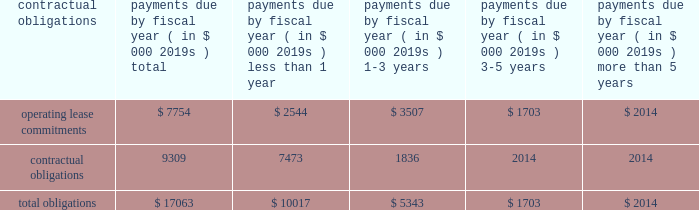97% ( 97 % ) of its carrying value .
The columbia fund is being liquidated with distributions to us occurring and expected to be fully liquidated during calendar 2008 .
Since december 2007 , we have received disbursements of approximately $ 20.7 million from the columbia fund .
Our operating activities during the year ended march 31 , 2008 used cash of $ 28.9 million as compared to $ 19.8 million during the same period in the prior year .
Our fiscal 2008 net loss of $ 40.9 million was the primary cause of our cash use from operations , attributed to increased investments in our global distribution as we continue to drive initiatives to increase recovery awareness as well as our investments in research and development to broaden our circulatory care product portfolio .
In addition , our inventories used cash of $ 11.1 million during fiscal 2008 , reflecting our inventory build-up to support anticipated increases in global demand for our products and our accounts receivable also increased as a result of higher sales volume resulting in a use of cash of $ 2.8 million in fiscal 2008 .
These decreases in cash were partially offset by an increase in accounts payable and accrued expenses of $ 5.6 million , non-cash adjustments of $ 5.4 million related to stock-based compensation expense , $ 6.1 million of depreciation and amortization and $ 5.0 million for the change in fair value of worldheart note receivable and warrant .
Our investing activities during the year ended march 31 , 2008 used cash of $ 40.9 million as compared to cash provided by investing activities of $ 15.1 million during the year ended march 31 , 2007 .
Cash used by investment activities for fiscal 2008 consisted primarily of $ 49.3 million for the recharacterization of the columbia fund to short-term marketable securities , $ 17.1 million for the purchase of short-term marketable securities , $ 3.8 million related to expenditures for property and equipment and $ 5.0 million for note receivable advanced to worldheart .
These amounts were offset by $ 34.5 million of proceeds from short-term marketable securities .
In june 2008 , we received 510 ( k ) clearance of our impella 2.5 , triggering an obligation to pay $ 5.6 million of contingent payments in accordance with the may 2005 acquisition of impella .
These contingent payments may be made , at our option , with cash , or stock or by a combination of cash or stock under circumstances described in the purchase agreement .
It is our intent to satisfy this contingent payment through the issuance of shares of our common stock .
Our financing activities during the year ended march 31 , 2008 provided cash of $ 2.1 million as compared to cash provided by financing activities of $ 66.6 million during the same period in the prior year .
Cash provided by financing activities for fiscal 2008 is comprised primarily of $ 2.8 million attributable to the exercise of stock options , $ 0.9 million related to the proceeds from the issuance of common stock , $ 0.3 million related to proceeds from the employee stock purchase plan , partially offset by $ 1.9 million related to the repurchase of warrants .
The $ 64.5 million decrease compared to the prior year is primarily due to $ 63.6 million raised from the public offering in fiscal 2007 .
We disbursed approximately $ 2.2 million of cash for the warrant repurchase and settlement of certain litigation .
Capital expenditures for fiscal 2009 are estimated to be approximately $ 3.0 to $ 6.0 million .
Contractual obligations and commercial commitments the table summarizes our contractual obligations at march 31 , 2008 and the effects such obligations are expected to have on our liquidity and cash flows in future periods .
Payments due by fiscal year ( in $ 000 2019s ) contractual obligations total than 1 than 5 .
We have no long-term debt , capital leases or other material commitments , for open purchase orders and clinical trial agreements at march 31 , 2008 other than those shown in the table above .
In may 2005 , we acquired all the shares of outstanding capital stock of impella cardiosystems ag , a company headquartered in aachen , germany .
The aggregate purchase price excluding a contingent payment in the amount of $ 5.6 million made on january 30 , 2007 in the form of common stock , was approximately $ 45.1 million , which consisted of $ 42.2 million of our common stock , $ 1.6 million of cash paid to certain former shareholders of impella and $ 1.3 million of transaction costs , consisting primarily of fees paid for financial advisory and legal services .
We may make additional contingent payments to impella 2019s former shareholders based on additional milestone payments related to fda approvals in the amount of up to $ 11.2 million .
In june 2008 we received 510 ( k ) clearance of our impella 2.5 , triggering an obligation to pay $ 5.6 million of contingent payments .
These contingent payments may be made , at our option , with cash , or stock or by a combination of cash or stock under circumstances described in the purchase agreement , except that approximately $ 1.8 million of these contingent payments must be made in cash .
The payment of any contingent payments will result in an increase to the carrying value of goodwill .
We apply the disclosure provisions of fin no .
45 , guarantor 2019s accounting and disclosure requirements for guarantees , including guarantees of indebtedness of others , and interpretation of fasb statements no .
5 , 57 and 107 and rescission of fasb interpretation .
What portion of total obligations is related to contractual obligations as of march 31 , 2008? 
Computations: (9309 / 17063)
Answer: 0.54557. 